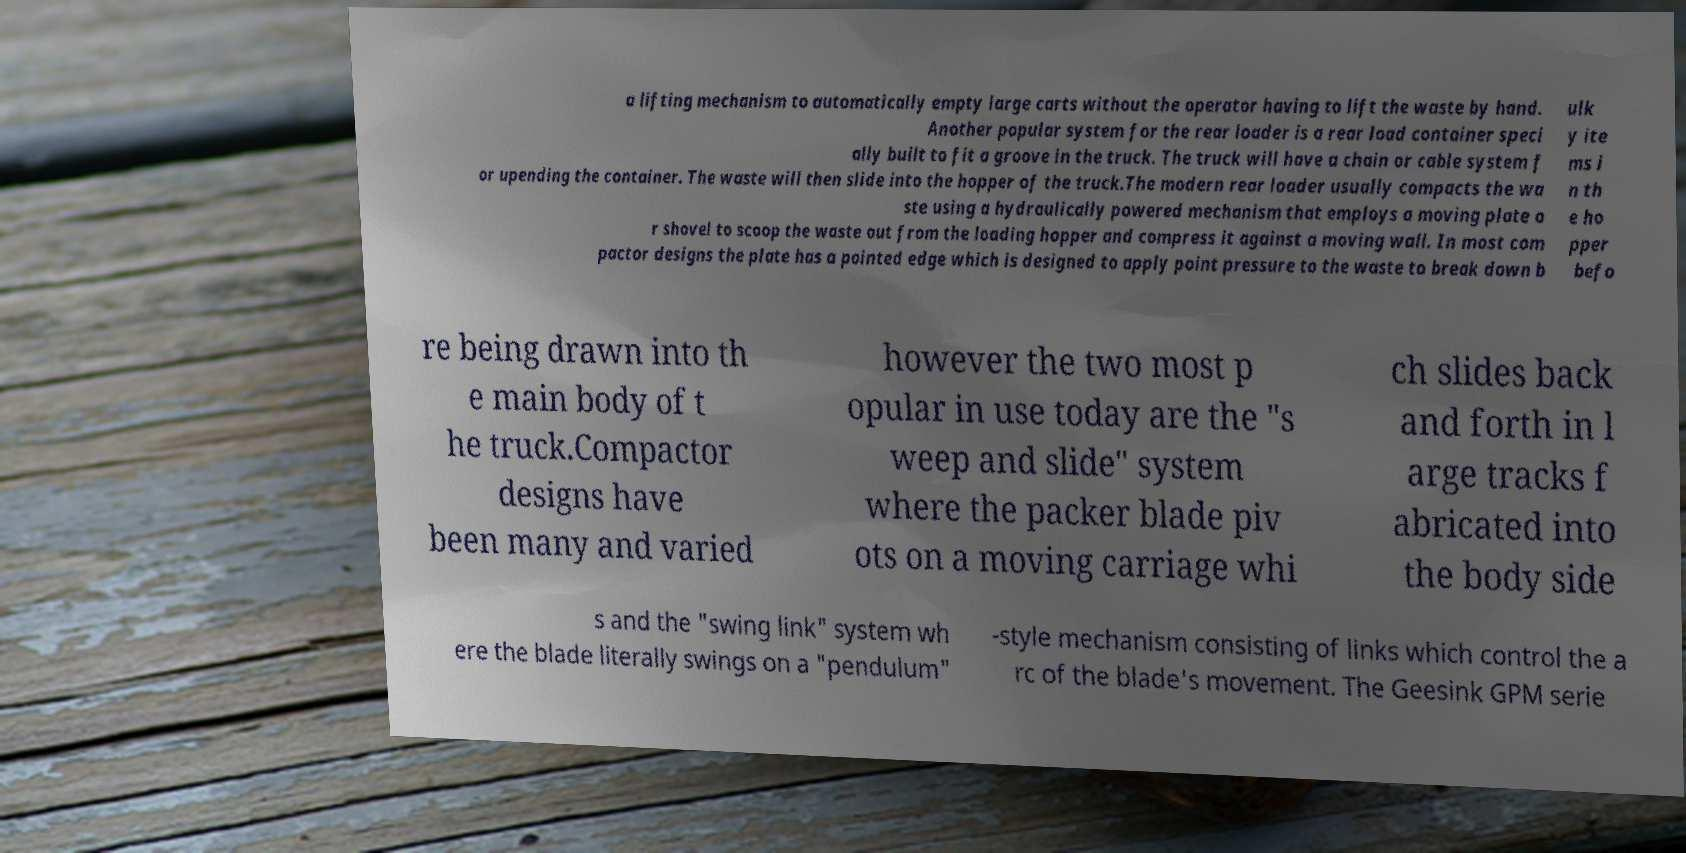Can you accurately transcribe the text from the provided image for me? a lifting mechanism to automatically empty large carts without the operator having to lift the waste by hand. Another popular system for the rear loader is a rear load container speci ally built to fit a groove in the truck. The truck will have a chain or cable system f or upending the container. The waste will then slide into the hopper of the truck.The modern rear loader usually compacts the wa ste using a hydraulically powered mechanism that employs a moving plate o r shovel to scoop the waste out from the loading hopper and compress it against a moving wall. In most com pactor designs the plate has a pointed edge which is designed to apply point pressure to the waste to break down b ulk y ite ms i n th e ho pper befo re being drawn into th e main body of t he truck.Compactor designs have been many and varied however the two most p opular in use today are the "s weep and slide" system where the packer blade piv ots on a moving carriage whi ch slides back and forth in l arge tracks f abricated into the body side s and the "swing link" system wh ere the blade literally swings on a "pendulum" -style mechanism consisting of links which control the a rc of the blade's movement. The Geesink GPM serie 